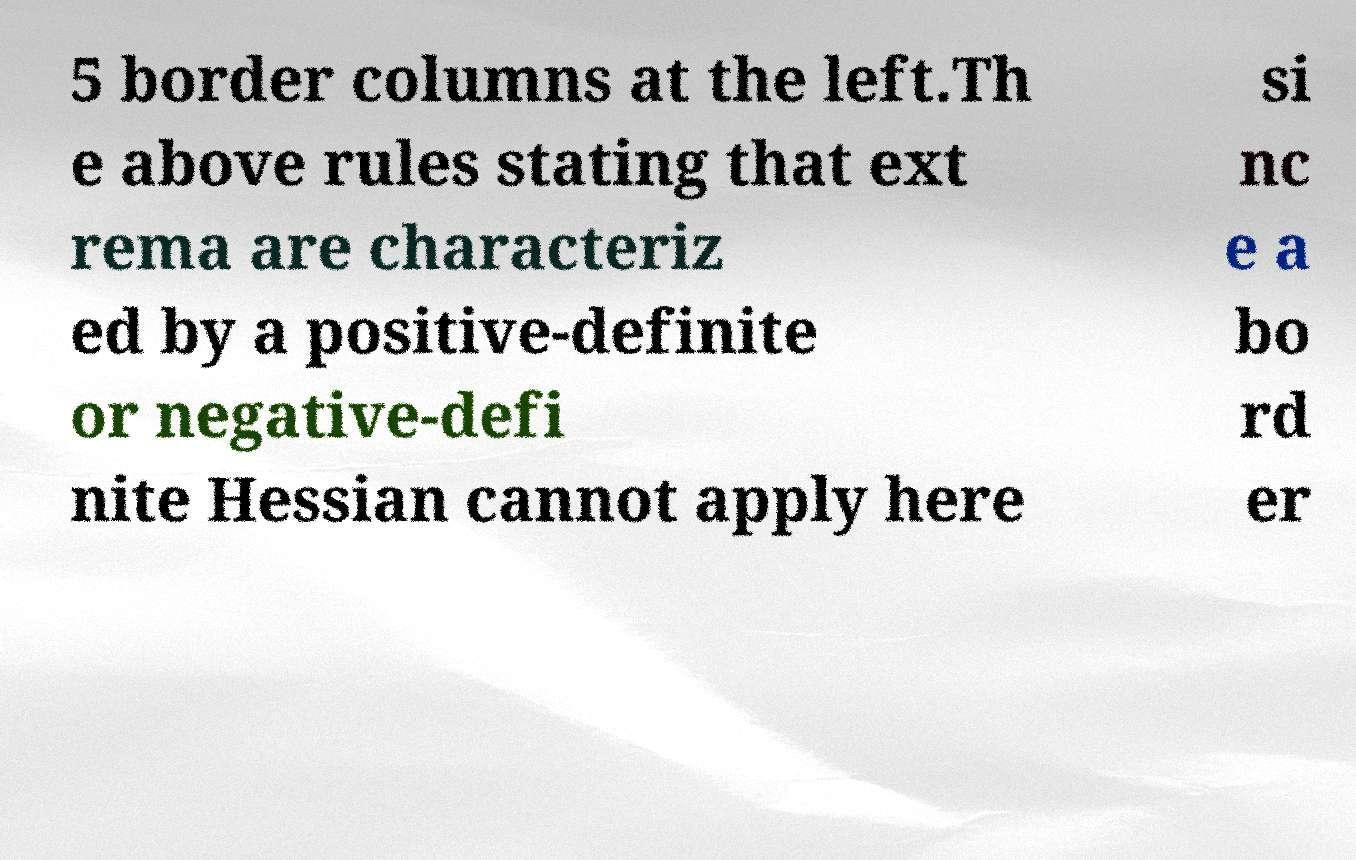Please read and relay the text visible in this image. What does it say? 5 border columns at the left.Th e above rules stating that ext rema are characteriz ed by a positive-definite or negative-defi nite Hessian cannot apply here si nc e a bo rd er 